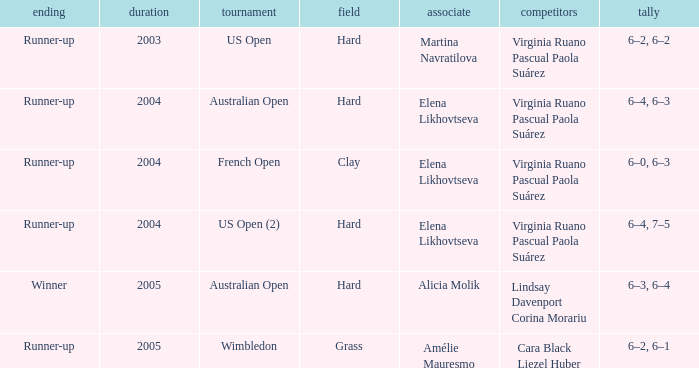When winner is the outcome what is the score? 6–3, 6–4. 